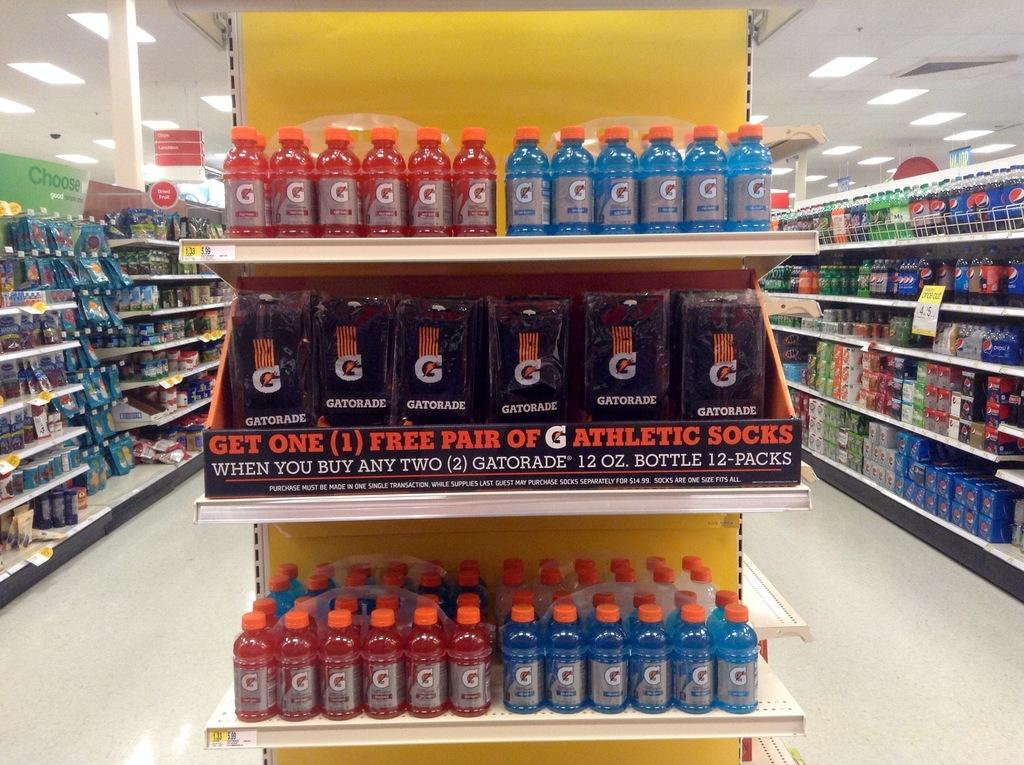<image>
Present a compact description of the photo's key features. An end cap at a store displays Gatorade athletic socks along with sports drinks. 